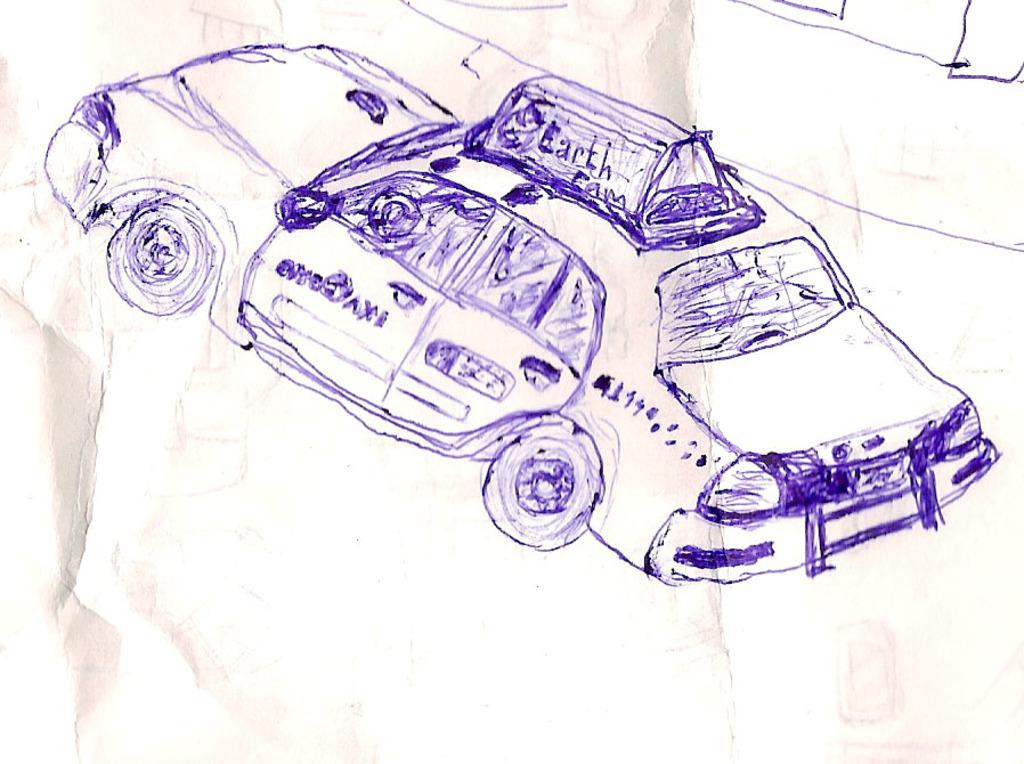What is the main subject of the sketch in the image? The main subject of the sketch in the image is a car. What color is the pen used to create the sketch? The sketch is made with a blue colored pen. What is the color of the paper on which the sketch is drawn? The sketch is on a white colored paper. How does the car in the sketch get a haircut in the image? There is no haircut depicted in the image, as it is a sketch of a car and not a living being. 